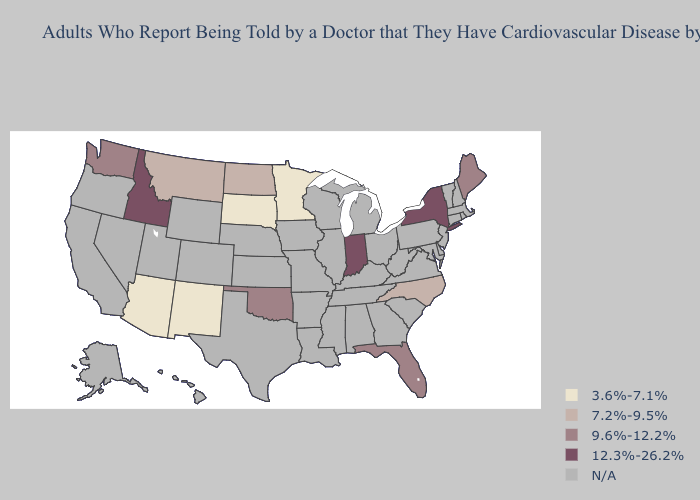Name the states that have a value in the range 9.6%-12.2%?
Quick response, please. Florida, Maine, Oklahoma, Washington. Does Maine have the lowest value in the USA?
Answer briefly. No. What is the lowest value in the South?
Short answer required. 7.2%-9.5%. Name the states that have a value in the range 3.6%-7.1%?
Concise answer only. Arizona, Minnesota, New Mexico, South Dakota. What is the value of Michigan?
Keep it brief. N/A. Which states hav the highest value in the MidWest?
Keep it brief. Indiana. Name the states that have a value in the range 9.6%-12.2%?
Keep it brief. Florida, Maine, Oklahoma, Washington. Which states hav the highest value in the Northeast?
Answer briefly. New York. Does Montana have the lowest value in the West?
Be succinct. No. What is the highest value in the South ?
Be succinct. 9.6%-12.2%. What is the highest value in the USA?
Concise answer only. 12.3%-26.2%. Name the states that have a value in the range 3.6%-7.1%?
Concise answer only. Arizona, Minnesota, New Mexico, South Dakota. Among the states that border Vermont , which have the lowest value?
Give a very brief answer. New York. Does New Mexico have the lowest value in the USA?
Quick response, please. Yes. What is the lowest value in the USA?
Keep it brief. 3.6%-7.1%. 